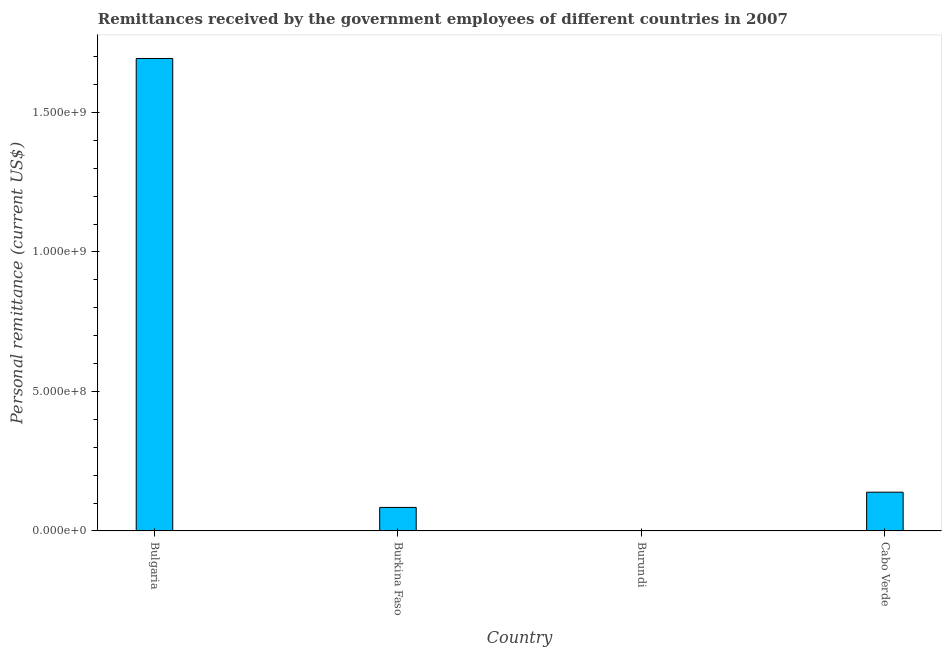Does the graph contain any zero values?
Keep it short and to the point. No. Does the graph contain grids?
Offer a very short reply. No. What is the title of the graph?
Provide a succinct answer. Remittances received by the government employees of different countries in 2007. What is the label or title of the Y-axis?
Your answer should be very brief. Personal remittance (current US$). What is the personal remittances in Cabo Verde?
Offer a terse response. 1.39e+08. Across all countries, what is the maximum personal remittances?
Your answer should be compact. 1.69e+09. Across all countries, what is the minimum personal remittances?
Give a very brief answer. 1.90e+05. In which country was the personal remittances maximum?
Your answer should be compact. Bulgaria. In which country was the personal remittances minimum?
Ensure brevity in your answer.  Burundi. What is the sum of the personal remittances?
Provide a short and direct response. 1.92e+09. What is the difference between the personal remittances in Burkina Faso and Burundi?
Your response must be concise. 8.41e+07. What is the average personal remittances per country?
Give a very brief answer. 4.79e+08. What is the median personal remittances?
Your answer should be very brief. 1.12e+08. In how many countries, is the personal remittances greater than 1100000000 US$?
Ensure brevity in your answer.  1. What is the difference between the highest and the second highest personal remittances?
Offer a very short reply. 1.55e+09. Is the sum of the personal remittances in Burkina Faso and Burundi greater than the maximum personal remittances across all countries?
Ensure brevity in your answer.  No. What is the difference between the highest and the lowest personal remittances?
Provide a short and direct response. 1.69e+09. In how many countries, is the personal remittances greater than the average personal remittances taken over all countries?
Keep it short and to the point. 1. Are the values on the major ticks of Y-axis written in scientific E-notation?
Your response must be concise. Yes. What is the Personal remittance (current US$) of Bulgaria?
Provide a short and direct response. 1.69e+09. What is the Personal remittance (current US$) of Burkina Faso?
Provide a succinct answer. 8.43e+07. What is the Personal remittance (current US$) of Burundi?
Offer a terse response. 1.90e+05. What is the Personal remittance (current US$) of Cabo Verde?
Your response must be concise. 1.39e+08. What is the difference between the Personal remittance (current US$) in Bulgaria and Burkina Faso?
Your response must be concise. 1.61e+09. What is the difference between the Personal remittance (current US$) in Bulgaria and Burundi?
Provide a succinct answer. 1.69e+09. What is the difference between the Personal remittance (current US$) in Bulgaria and Cabo Verde?
Offer a very short reply. 1.55e+09. What is the difference between the Personal remittance (current US$) in Burkina Faso and Burundi?
Ensure brevity in your answer.  8.41e+07. What is the difference between the Personal remittance (current US$) in Burkina Faso and Cabo Verde?
Keep it short and to the point. -5.45e+07. What is the difference between the Personal remittance (current US$) in Burundi and Cabo Verde?
Ensure brevity in your answer.  -1.39e+08. What is the ratio of the Personal remittance (current US$) in Bulgaria to that in Burkina Faso?
Offer a very short reply. 20.08. What is the ratio of the Personal remittance (current US$) in Bulgaria to that in Burundi?
Provide a short and direct response. 8915.83. What is the ratio of the Personal remittance (current US$) in Bulgaria to that in Cabo Verde?
Offer a very short reply. 12.2. What is the ratio of the Personal remittance (current US$) in Burkina Faso to that in Burundi?
Keep it short and to the point. 443.93. What is the ratio of the Personal remittance (current US$) in Burkina Faso to that in Cabo Verde?
Provide a succinct answer. 0.61. What is the ratio of the Personal remittance (current US$) in Burundi to that in Cabo Verde?
Keep it short and to the point. 0. 